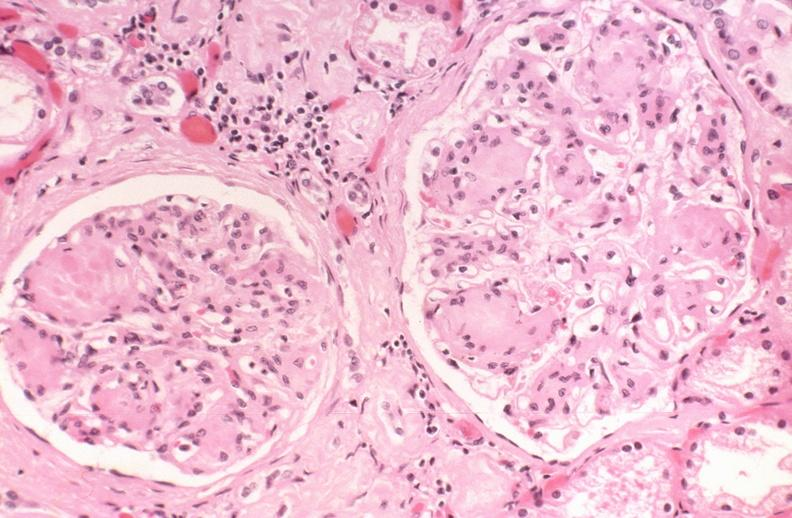what does this image show?
Answer the question using a single word or phrase. Kidney glomerulus 